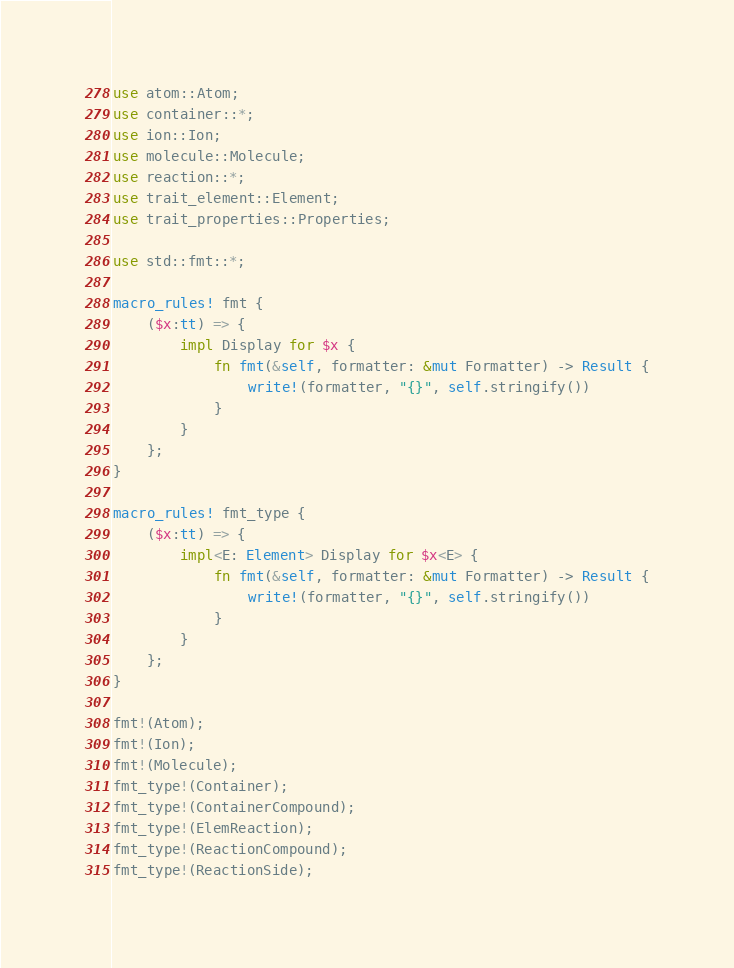<code> <loc_0><loc_0><loc_500><loc_500><_Rust_>use atom::Atom;
use container::*;
use ion::Ion;
use molecule::Molecule;
use reaction::*;
use trait_element::Element;
use trait_properties::Properties;

use std::fmt::*;

macro_rules! fmt {
    ($x:tt) => {
        impl Display for $x {
            fn fmt(&self, formatter: &mut Formatter) -> Result {
                write!(formatter, "{}", self.stringify())
            }
        }
    };
}

macro_rules! fmt_type {
    ($x:tt) => {
        impl<E: Element> Display for $x<E> {
            fn fmt(&self, formatter: &mut Formatter) -> Result {
                write!(formatter, "{}", self.stringify())
            }
        }
    };
}

fmt!(Atom);
fmt!(Ion);
fmt!(Molecule);
fmt_type!(Container);
fmt_type!(ContainerCompound);
fmt_type!(ElemReaction);
fmt_type!(ReactionCompound);
fmt_type!(ReactionSide);
</code> 